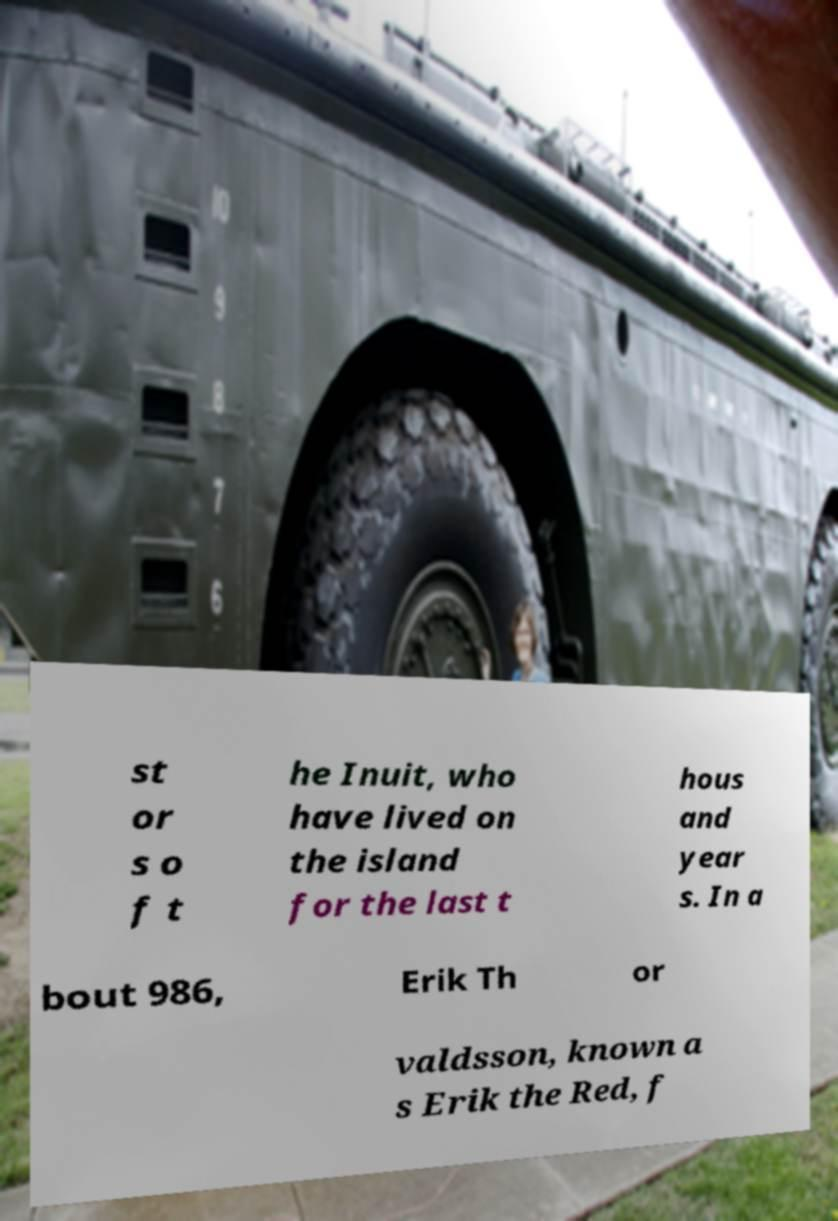Please read and relay the text visible in this image. What does it say? st or s o f t he Inuit, who have lived on the island for the last t hous and year s. In a bout 986, Erik Th or valdsson, known a s Erik the Red, f 